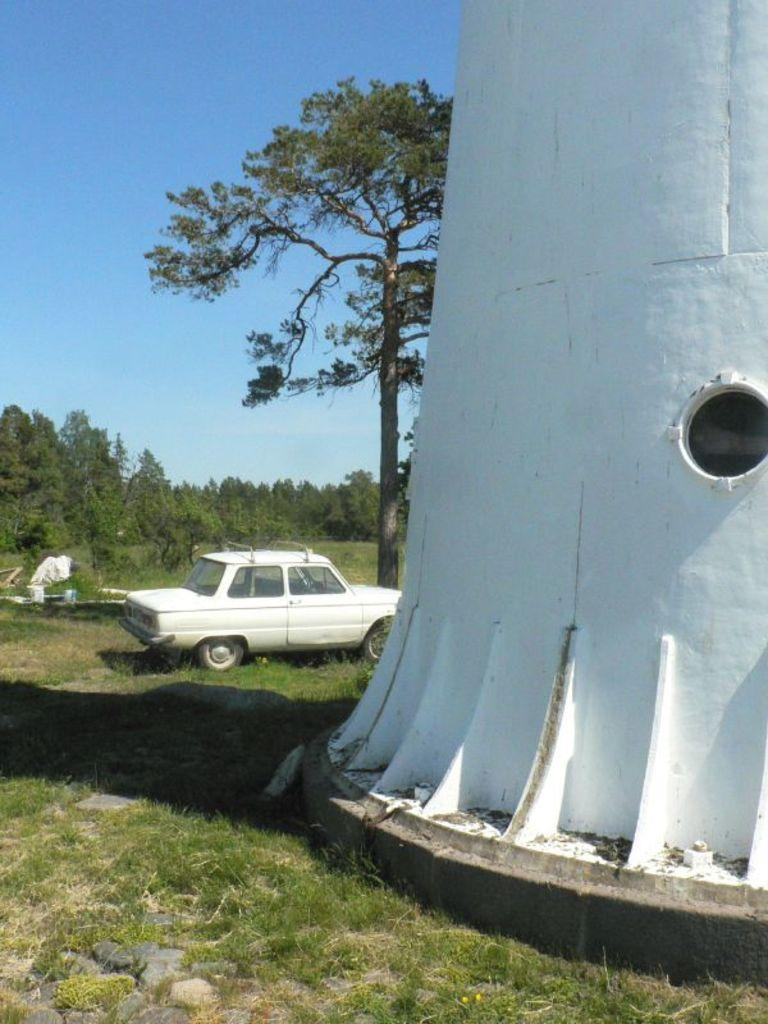What is the main structure in the image? There is a tower in the image. What else can be seen near the tower? There is a vehicle near the tower. What type of natural elements are present in the image? There are many trees in the image. What is the color of the sky in the background? The blue sky is visible in the background. What type of bubble can be seen floating near the tower in the image? There is no bubble present in the image. Is there a vest hanging on the tower in the image? There is no vest visible in the image. 